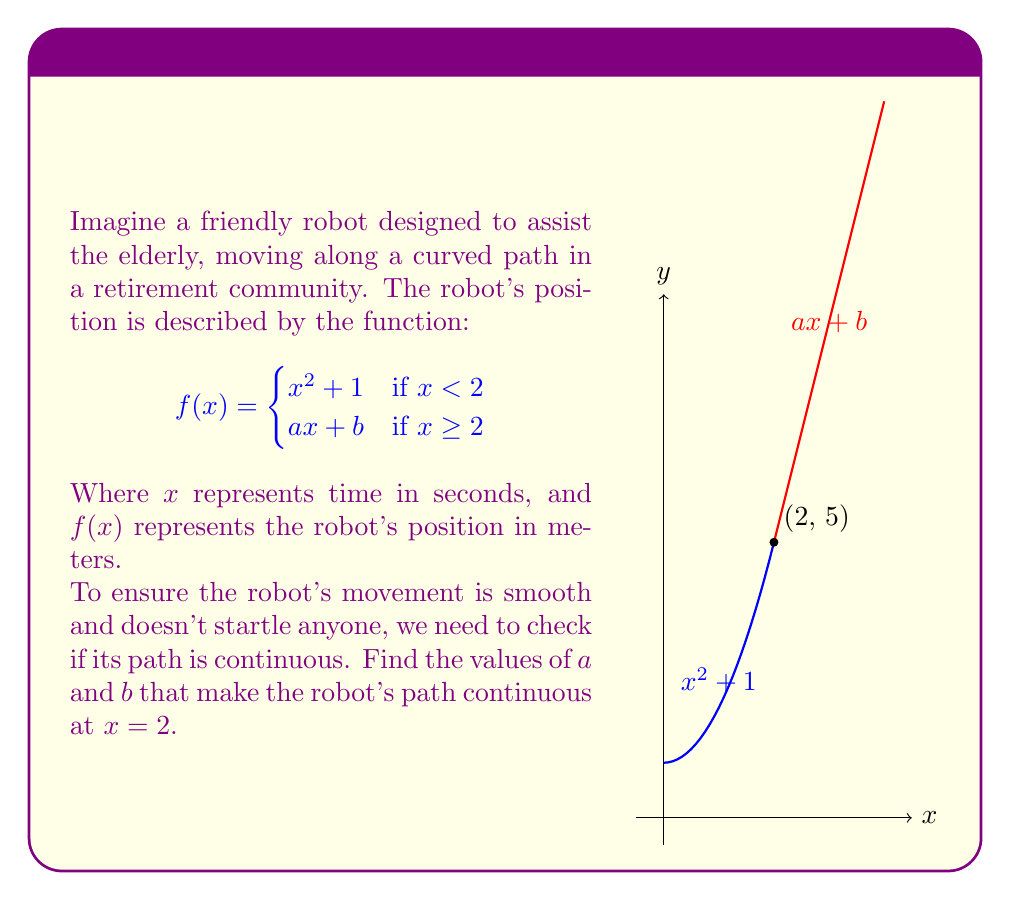What is the answer to this math problem? Let's approach this step-by-step:

1) For a function to be continuous at a point, the limit of the function as we approach the point from both sides must exist and be equal to the function's value at that point.

2) At $x = 2$, we need:
   $$\lim_{x \to 2^-} f(x) = \lim_{x \to 2^+} f(x) = f(2)$$

3) From the left side ($x < 2$):
   $$\lim_{x \to 2^-} f(x) = \lim_{x \to 2^-} (x^2 + 1) = 2^2 + 1 = 5$$

4) From the right side ($x \geq 2$):
   $$\lim_{x \to 2^+} f(x) = \lim_{x \to 2^+} (ax + b) = 2a + b$$

5) For continuity, we need:
   $$2a + b = 5$$ (Equation 1)

6) We also need the function to equal 5 when $x = 2$:
   $$f(2) = a(2) + b = 5$$
   $$2a + b = 5$$ (Equation 2)

7) We have two equations that are identical:
   $$2a + b = 5$$

8) We need one more equation to solve for both $a$ and $b$. We can get this by ensuring the derivatives match at $x = 2$:
   $$\lim_{x \to 2^-} f'(x) = \lim_{x \to 2^+} f'(x)$$
   $$\lim_{x \to 2^-} (2x) = a$$
   $$4 = a$$

9) Substituting $a = 4$ into our equation:
   $$2(4) + b = 5$$
   $$8 + b = 5$$
   $$b = -3$$

Therefore, $a = 4$ and $b = -3$ make the robot's path continuous at $x = 2$.
Answer: $a = 4, b = -3$ 